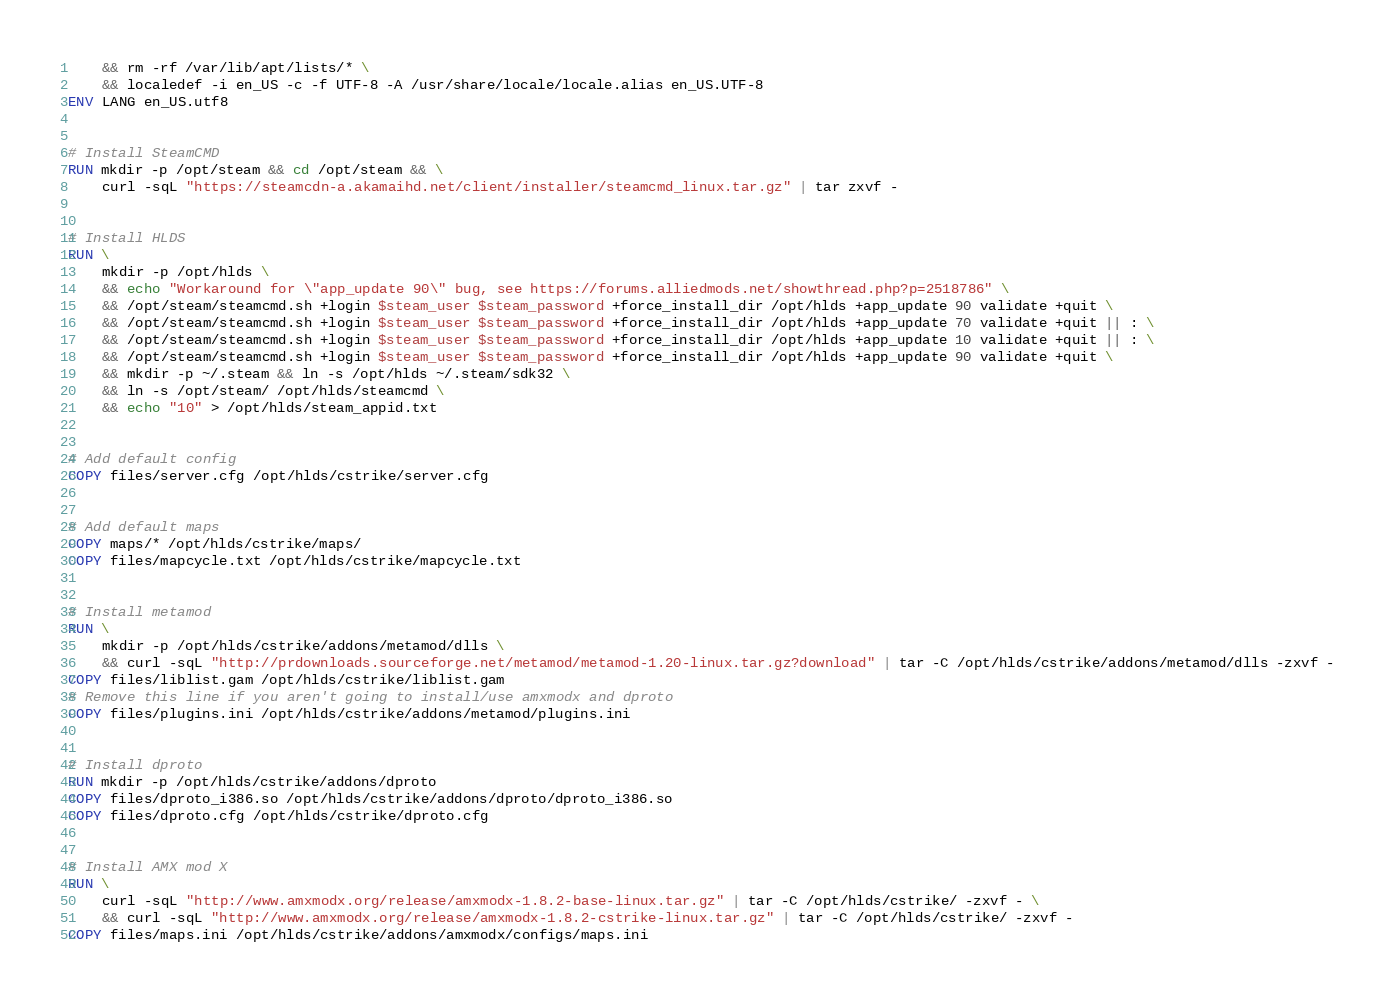<code> <loc_0><loc_0><loc_500><loc_500><_Dockerfile_>    && rm -rf /var/lib/apt/lists/* \
    && localedef -i en_US -c -f UTF-8 -A /usr/share/locale/locale.alias en_US.UTF-8
ENV LANG en_US.utf8


# Install SteamCMD
RUN mkdir -p /opt/steam && cd /opt/steam && \
    curl -sqL "https://steamcdn-a.akamaihd.net/client/installer/steamcmd_linux.tar.gz" | tar zxvf -


# Install HLDS
RUN \
    mkdir -p /opt/hlds \
    && echo "Workaround for \"app_update 90\" bug, see https://forums.alliedmods.net/showthread.php?p=2518786" \
    && /opt/steam/steamcmd.sh +login $steam_user $steam_password +force_install_dir /opt/hlds +app_update 90 validate +quit \
    && /opt/steam/steamcmd.sh +login $steam_user $steam_password +force_install_dir /opt/hlds +app_update 70 validate +quit || : \
    && /opt/steam/steamcmd.sh +login $steam_user $steam_password +force_install_dir /opt/hlds +app_update 10 validate +quit || : \
    && /opt/steam/steamcmd.sh +login $steam_user $steam_password +force_install_dir /opt/hlds +app_update 90 validate +quit \
    && mkdir -p ~/.steam && ln -s /opt/hlds ~/.steam/sdk32 \
    && ln -s /opt/steam/ /opt/hlds/steamcmd \
    && echo "10" > /opt/hlds/steam_appid.txt


# Add default config
COPY files/server.cfg /opt/hlds/cstrike/server.cfg


# Add default maps
COPY maps/* /opt/hlds/cstrike/maps/
COPY files/mapcycle.txt /opt/hlds/cstrike/mapcycle.txt


# Install metamod
RUN \
    mkdir -p /opt/hlds/cstrike/addons/metamod/dlls \
    && curl -sqL "http://prdownloads.sourceforge.net/metamod/metamod-1.20-linux.tar.gz?download" | tar -C /opt/hlds/cstrike/addons/metamod/dlls -zxvf -
COPY files/liblist.gam /opt/hlds/cstrike/liblist.gam
# Remove this line if you aren't going to install/use amxmodx and dproto
COPY files/plugins.ini /opt/hlds/cstrike/addons/metamod/plugins.ini


# Install dproto
RUN mkdir -p /opt/hlds/cstrike/addons/dproto
COPY files/dproto_i386.so /opt/hlds/cstrike/addons/dproto/dproto_i386.so
COPY files/dproto.cfg /opt/hlds/cstrike/dproto.cfg


# Install AMX mod X
RUN \
    curl -sqL "http://www.amxmodx.org/release/amxmodx-1.8.2-base-linux.tar.gz" | tar -C /opt/hlds/cstrike/ -zxvf - \
    && curl -sqL "http://www.amxmodx.org/release/amxmodx-1.8.2-cstrike-linux.tar.gz" | tar -C /opt/hlds/cstrike/ -zxvf -
COPY files/maps.ini /opt/hlds/cstrike/addons/amxmodx/configs/maps.ini

</code> 